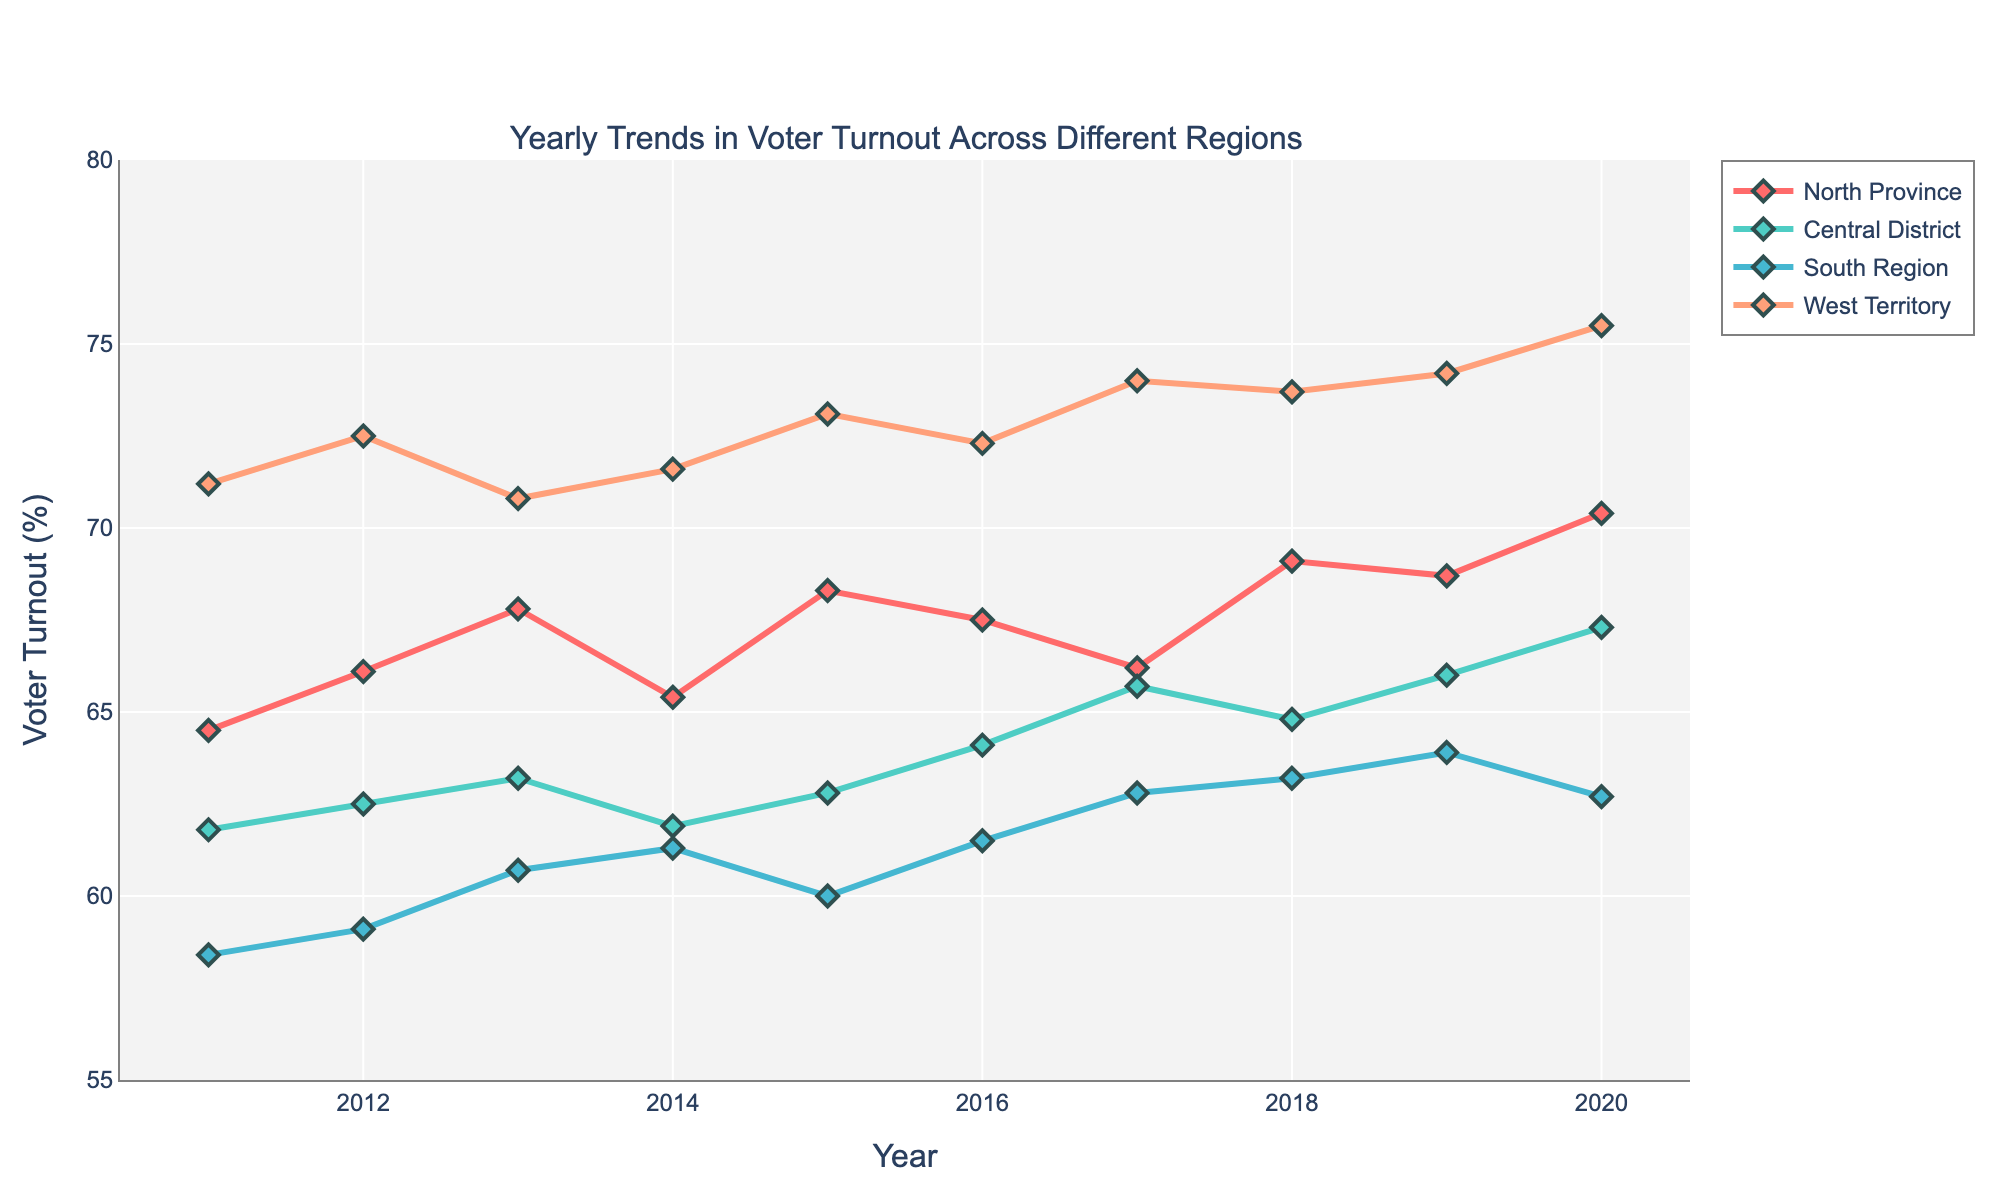Which region experienced the highest voter turnout in 2020? To determine the highest voter turnout in 2020, look at the data points for each region in that year. The West Territory has the highest value at 75.5%.
Answer: West Territory How did the voter turnout in the North Province change from 2011 to 2020? Compare the voter turnout values in the North Province for the years 2011 (64.5%) and 2020 (70.4%). The increase can be calculated as 70.4% - 64.5% = 5.9%.
Answer: Increased by 5.9% Which region shows the most consistent trend in voter turnout over the years? To identify the most consistent trend, look for the region with the smallest fluctuations in the time series. The Central District shows a relatively stable trend compared to the others.
Answer: Central District What is the average voter turnout in the South Region from 2011 to 2020? Calculate the average by summing all voter turnout percentages for the South Region from 2011 to 2020 and then dividing by the number of years. (58.4 + 59.1 + 60.7 + 61.3 + 60.0 + 61.5 + 62.8 + 63.2 + 63.9 + 62.7) / 10 = 61.36%
Answer: 61.36% Which year had the highest overall voter turnout across all regions? Look at the highest data points for all years collectively in the figure. The highest voter turnout is 75.5% in 2020 from the West Territory.
Answer: 2020 How does the voter turnout in the Central District in 2012 compare to that in 2019? Compare the values for Central District in 2012 and 2019. In 2012 the percentage is 62.5% and in 2019 it is 66.0%. The voter turnout increased by 66.0% - 62.5% = 3.5%.
Answer: Increased by 3.5% Which region experienced the largest decrease in voter turnout in any single year? Identify the largest drop in the trend lines for each region. The largest decrease is in the South Region from 2019 to 2020 where the voter turnout dropped from 63.9% to 62.7% which is a 1.2% decrease.
Answer: South Region from 2019 to 2020 What is the general trend in voter turnout for the West Territory from 2011 to 2020? Observe the overall slope of the voter turnout line for the West Territory. The trend shows a general increase from 71.2% in 2011 to 75.5% in 2020.
Answer: Increasing trend How does the voter turnout in the North Province in 2015 compare to the South Region in the same year? Compare the values for both regions in 2015. North Province had a turnout of 68.3% whereas the South Region had 60.0%. North Province had a higher turnout by 68.3% - 60.0% = 8.3%.
Answer: North Province by 8.3% Which region experienced the highest increase in voter turnout between consecutive years? Determine the highest increase by observing the year-over-year changes in each plot. The West Territory experienced a significant increase from 2017 to 2018, going from 74.0% to 73.7%, (which actually decreased). Therefore, it seems a significant increase was actually from 2012 to 2013 in the South Region, increasing from 59.1% to 60.7%, resulting in a 1.6% increase.
Answer: South Region from 2012 to 2013 by 1.6% 